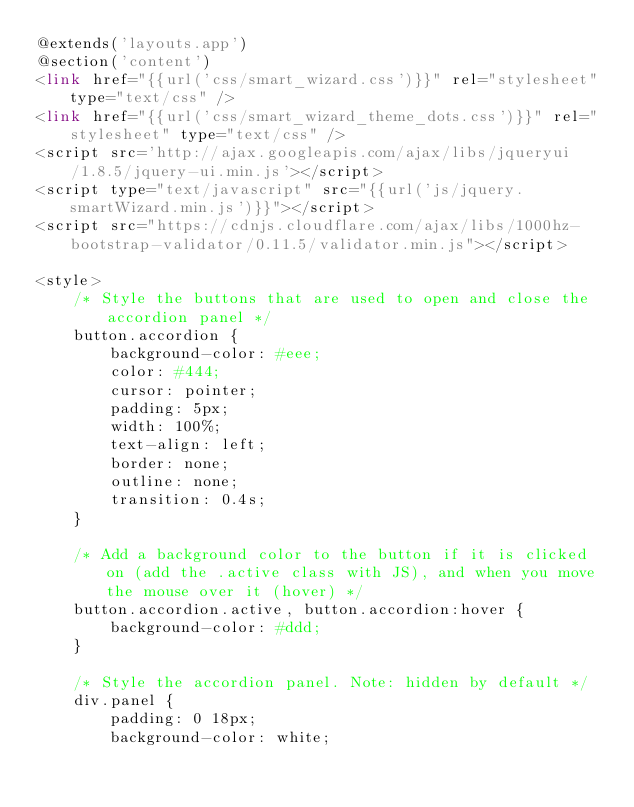<code> <loc_0><loc_0><loc_500><loc_500><_PHP_>@extends('layouts.app')
@section('content')
<link href="{{url('css/smart_wizard.css')}}" rel="stylesheet" type="text/css" />
<link href="{{url('css/smart_wizard_theme_dots.css')}}" rel="stylesheet" type="text/css" />
<script src='http://ajax.googleapis.com/ajax/libs/jqueryui/1.8.5/jquery-ui.min.js'></script>
<script type="text/javascript" src="{{url('js/jquery.smartWizard.min.js')}}"></script>
<script src="https://cdnjs.cloudflare.com/ajax/libs/1000hz-bootstrap-validator/0.11.5/validator.min.js"></script>

<style>
    /* Style the buttons that are used to open and close the accordion panel */
    button.accordion {
        background-color: #eee;
        color: #444;
        cursor: pointer;
        padding: 5px;
        width: 100%;
        text-align: left;
        border: none;
        outline: none;
        transition: 0.4s;
    }

    /* Add a background color to the button if it is clicked on (add the .active class with JS), and when you move the mouse over it (hover) */
    button.accordion.active, button.accordion:hover {
        background-color: #ddd;
    }

    /* Style the accordion panel. Note: hidden by default */
    div.panel {
        padding: 0 18px;
        background-color: white;</code> 